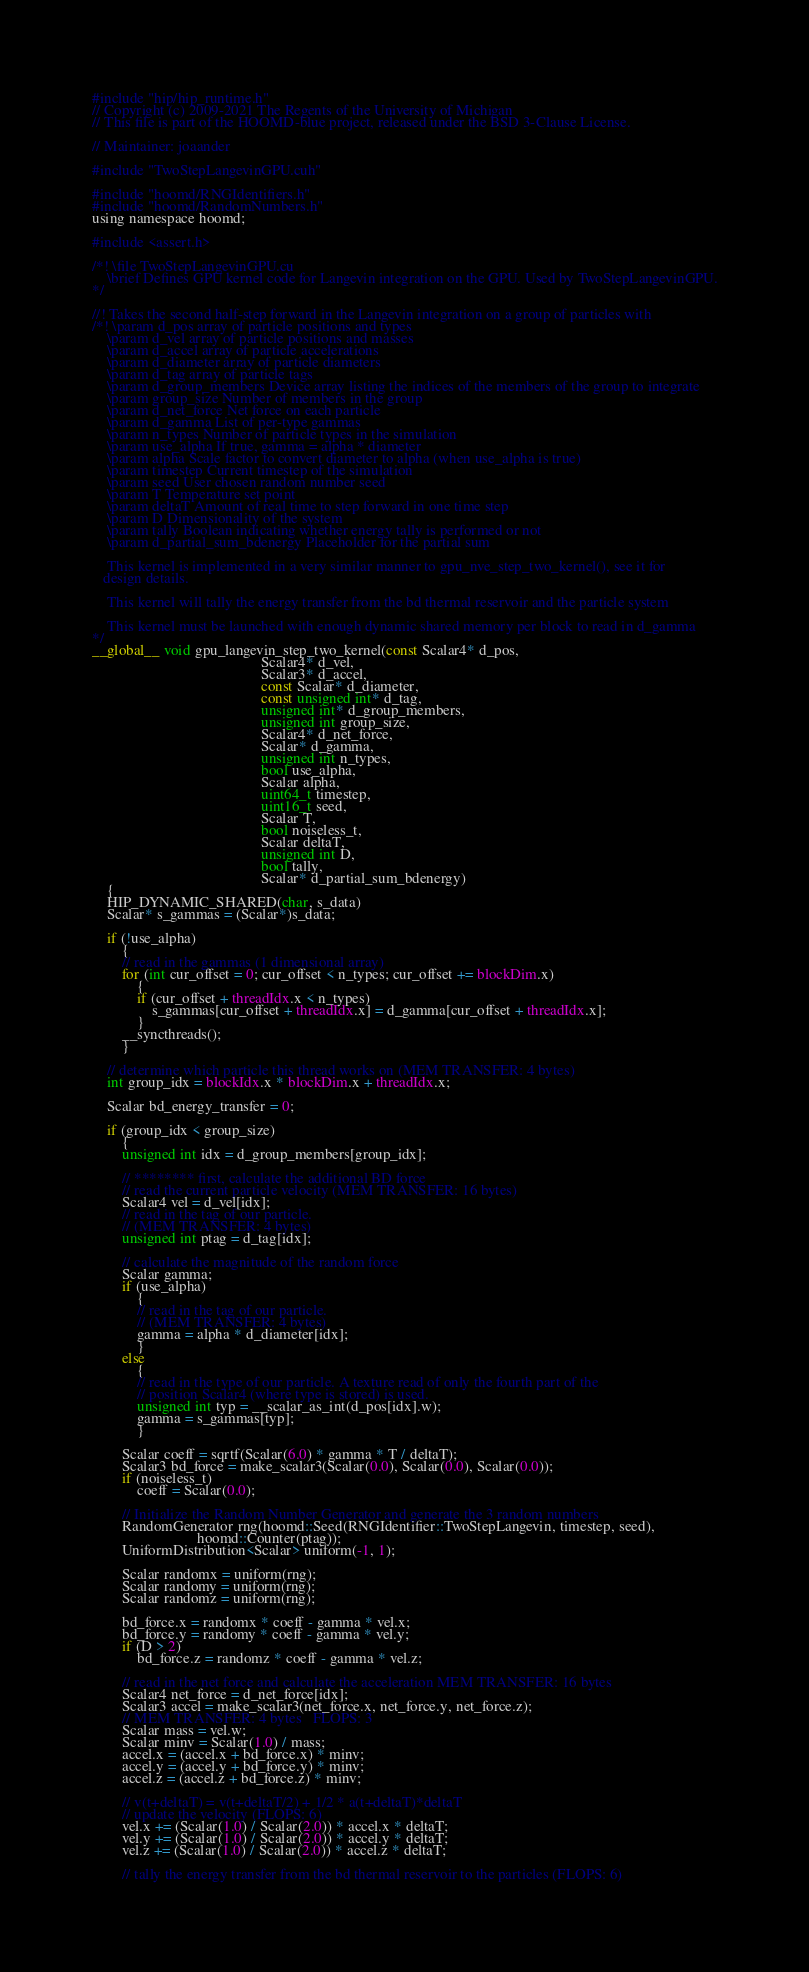<code> <loc_0><loc_0><loc_500><loc_500><_Cuda_>#include "hip/hip_runtime.h"
// Copyright (c) 2009-2021 The Regents of the University of Michigan
// This file is part of the HOOMD-blue project, released under the BSD 3-Clause License.

// Maintainer: joaander

#include "TwoStepLangevinGPU.cuh"

#include "hoomd/RNGIdentifiers.h"
#include "hoomd/RandomNumbers.h"
using namespace hoomd;

#include <assert.h>

/*! \file TwoStepLangevinGPU.cu
    \brief Defines GPU kernel code for Langevin integration on the GPU. Used by TwoStepLangevinGPU.
*/

//! Takes the second half-step forward in the Langevin integration on a group of particles with
/*! \param d_pos array of particle positions and types
    \param d_vel array of particle positions and masses
    \param d_accel array of particle accelerations
    \param d_diameter array of particle diameters
    \param d_tag array of particle tags
    \param d_group_members Device array listing the indices of the members of the group to integrate
    \param group_size Number of members in the group
    \param d_net_force Net force on each particle
    \param d_gamma List of per-type gammas
    \param n_types Number of particle types in the simulation
    \param use_alpha If true, gamma = alpha * diameter
    \param alpha Scale factor to convert diameter to alpha (when use_alpha is true)
    \param timestep Current timestep of the simulation
    \param seed User chosen random number seed
    \param T Temperature set point
    \param deltaT Amount of real time to step forward in one time step
    \param D Dimensionality of the system
    \param tally Boolean indicating whether energy tally is performed or not
    \param d_partial_sum_bdenergy Placeholder for the partial sum

    This kernel is implemented in a very similar manner to gpu_nve_step_two_kernel(), see it for
   design details.

    This kernel will tally the energy transfer from the bd thermal reservoir and the particle system

    This kernel must be launched with enough dynamic shared memory per block to read in d_gamma
*/
__global__ void gpu_langevin_step_two_kernel(const Scalar4* d_pos,
                                             Scalar4* d_vel,
                                             Scalar3* d_accel,
                                             const Scalar* d_diameter,
                                             const unsigned int* d_tag,
                                             unsigned int* d_group_members,
                                             unsigned int group_size,
                                             Scalar4* d_net_force,
                                             Scalar* d_gamma,
                                             unsigned int n_types,
                                             bool use_alpha,
                                             Scalar alpha,
                                             uint64_t timestep,
                                             uint16_t seed,
                                             Scalar T,
                                             bool noiseless_t,
                                             Scalar deltaT,
                                             unsigned int D,
                                             bool tally,
                                             Scalar* d_partial_sum_bdenergy)
    {
    HIP_DYNAMIC_SHARED(char, s_data)
    Scalar* s_gammas = (Scalar*)s_data;

    if (!use_alpha)
        {
        // read in the gammas (1 dimensional array)
        for (int cur_offset = 0; cur_offset < n_types; cur_offset += blockDim.x)
            {
            if (cur_offset + threadIdx.x < n_types)
                s_gammas[cur_offset + threadIdx.x] = d_gamma[cur_offset + threadIdx.x];
            }
        __syncthreads();
        }

    // determine which particle this thread works on (MEM TRANSFER: 4 bytes)
    int group_idx = blockIdx.x * blockDim.x + threadIdx.x;

    Scalar bd_energy_transfer = 0;

    if (group_idx < group_size)
        {
        unsigned int idx = d_group_members[group_idx];

        // ******** first, calculate the additional BD force
        // read the current particle velocity (MEM TRANSFER: 16 bytes)
        Scalar4 vel = d_vel[idx];
        // read in the tag of our particle.
        // (MEM TRANSFER: 4 bytes)
        unsigned int ptag = d_tag[idx];

        // calculate the magnitude of the random force
        Scalar gamma;
        if (use_alpha)
            {
            // read in the tag of our particle.
            // (MEM TRANSFER: 4 bytes)
            gamma = alpha * d_diameter[idx];
            }
        else
            {
            // read in the type of our particle. A texture read of only the fourth part of the
            // position Scalar4 (where type is stored) is used.
            unsigned int typ = __scalar_as_int(d_pos[idx].w);
            gamma = s_gammas[typ];
            }

        Scalar coeff = sqrtf(Scalar(6.0) * gamma * T / deltaT);
        Scalar3 bd_force = make_scalar3(Scalar(0.0), Scalar(0.0), Scalar(0.0));
        if (noiseless_t)
            coeff = Scalar(0.0);

        // Initialize the Random Number Generator and generate the 3 random numbers
        RandomGenerator rng(hoomd::Seed(RNGIdentifier::TwoStepLangevin, timestep, seed),
                            hoomd::Counter(ptag));
        UniformDistribution<Scalar> uniform(-1, 1);

        Scalar randomx = uniform(rng);
        Scalar randomy = uniform(rng);
        Scalar randomz = uniform(rng);

        bd_force.x = randomx * coeff - gamma * vel.x;
        bd_force.y = randomy * coeff - gamma * vel.y;
        if (D > 2)
            bd_force.z = randomz * coeff - gamma * vel.z;

        // read in the net force and calculate the acceleration MEM TRANSFER: 16 bytes
        Scalar4 net_force = d_net_force[idx];
        Scalar3 accel = make_scalar3(net_force.x, net_force.y, net_force.z);
        // MEM TRANSFER: 4 bytes   FLOPS: 3
        Scalar mass = vel.w;
        Scalar minv = Scalar(1.0) / mass;
        accel.x = (accel.x + bd_force.x) * minv;
        accel.y = (accel.y + bd_force.y) * minv;
        accel.z = (accel.z + bd_force.z) * minv;

        // v(t+deltaT) = v(t+deltaT/2) + 1/2 * a(t+deltaT)*deltaT
        // update the velocity (FLOPS: 6)
        vel.x += (Scalar(1.0) / Scalar(2.0)) * accel.x * deltaT;
        vel.y += (Scalar(1.0) / Scalar(2.0)) * accel.y * deltaT;
        vel.z += (Scalar(1.0) / Scalar(2.0)) * accel.z * deltaT;

        // tally the energy transfer from the bd thermal reservoir to the particles (FLOPS: 6)</code> 